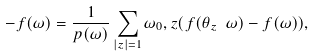Convert formula to latex. <formula><loc_0><loc_0><loc_500><loc_500>- \L f ( \omega ) = \frac { 1 } { p ( \omega ) } \sum _ { | z | = 1 } \omega _ { 0 } , z ( f ( \theta _ { z } \ \omega ) - f ( \omega ) ) ,</formula> 